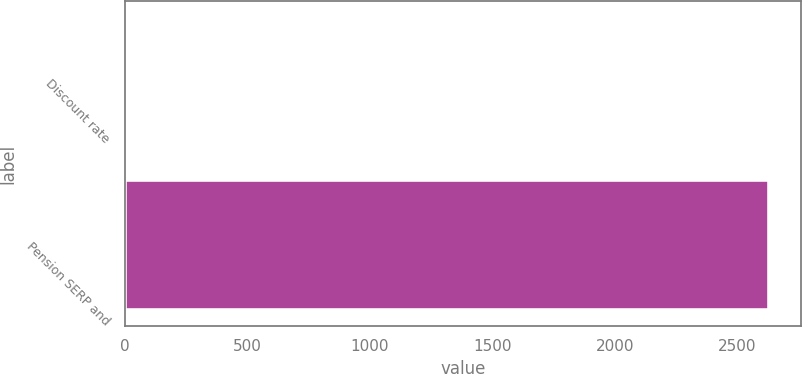<chart> <loc_0><loc_0><loc_500><loc_500><bar_chart><fcel>Discount rate<fcel>Pension SERP and<nl><fcel>3.5<fcel>2627<nl></chart> 